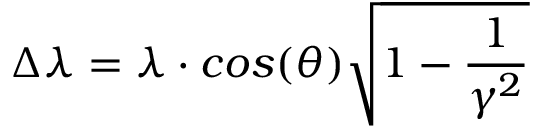<formula> <loc_0><loc_0><loc_500><loc_500>\Delta \lambda = \lambda \cdot \cos ( \theta ) \sqrt { 1 - \frac { 1 } { \gamma ^ { 2 } } }</formula> 